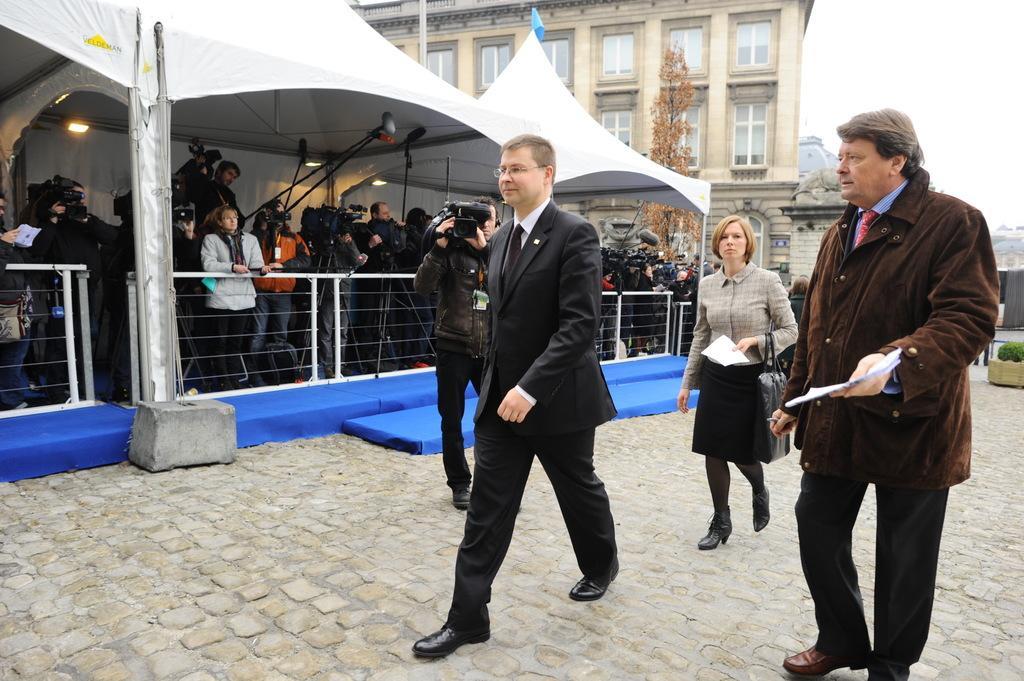Could you give a brief overview of what you see in this image? In this image we can see a few people standing, among them, some are holding the objects, also we can see a building and a tent, there are railings, lights, plant and a tree. 